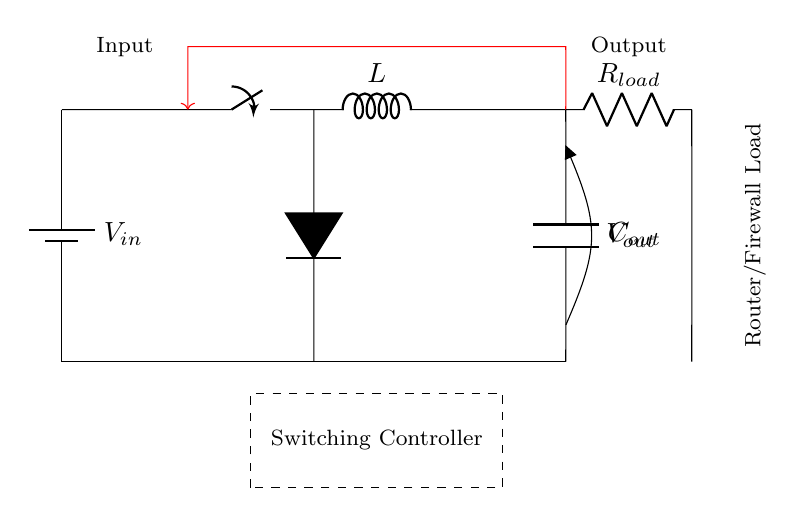What is the input voltage source labeled as? The input voltage source in the circuit is labeled as V subscript in, indicating it is the voltage supplied to the circuit.
Answer: Vin What component is located directly after the switch? Directly after the switch, there is an inductor labeled as L, which is used to store energy in a magnetic field.
Answer: L What is the function of the diode in this circuit? The diode in the circuit allows current to flow in one direction, preventing backflow which protects components from reverse voltage.
Answer: Prevents backflow How many primary components are in the circuit? The primary components of the circuit diagram are the battery, switch, inductor, diode, capacitor, and load resistor, totaling six main components.
Answer: Six What does the dashed rectangle in the diagram represent? The dashed rectangle symbolizes the switching controller, which regulates the operation of the switch and manages energy transfer in the circuit.
Answer: Switching Controller Which component is responsible for output voltage stabilization? The output capacitor labeled as C subscript out helps to stabilize and smooth the output voltage provided to the load.
Answer: Cout What type of circuit is depicted in the diagram? The circuit shown is a switching voltage regulator circuit, specifically designed for efficient power management in applications like routers and firewalls.
Answer: Switching Voltage Regulator 